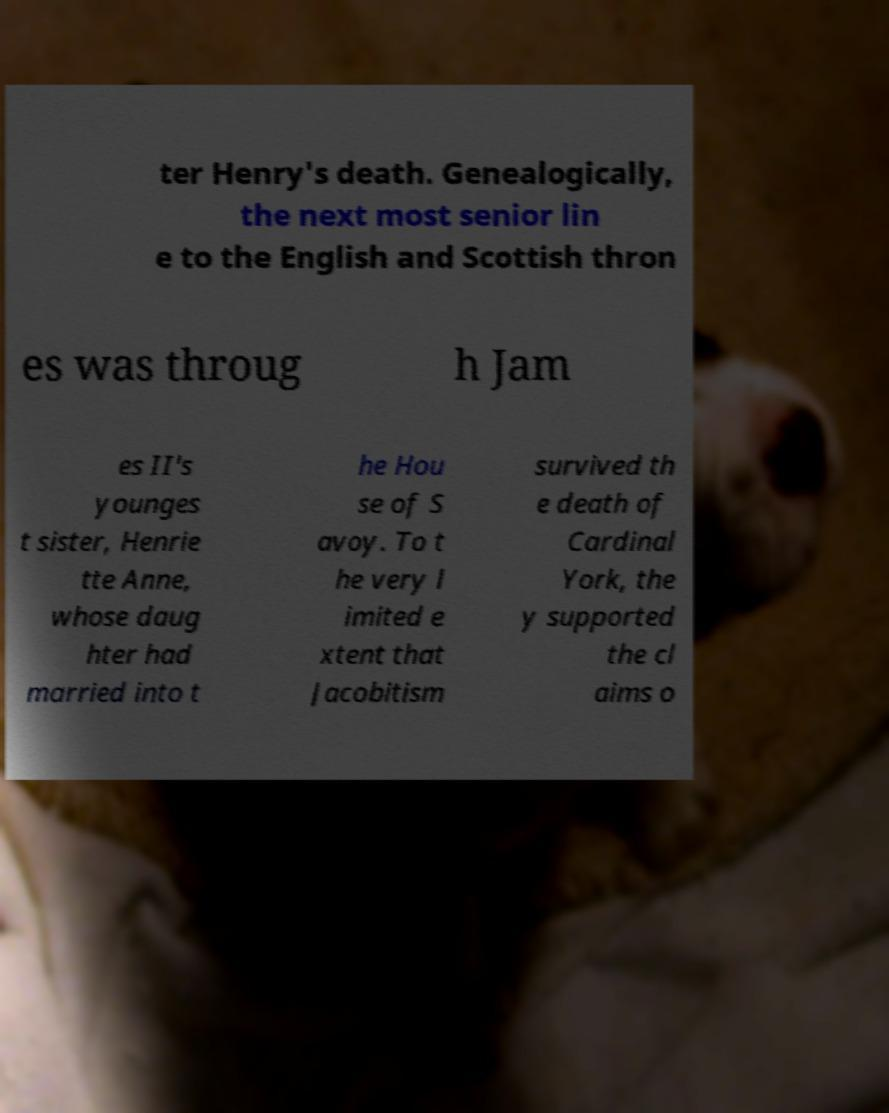Please read and relay the text visible in this image. What does it say? ter Henry's death. Genealogically, the next most senior lin e to the English and Scottish thron es was throug h Jam es II's younges t sister, Henrie tte Anne, whose daug hter had married into t he Hou se of S avoy. To t he very l imited e xtent that Jacobitism survived th e death of Cardinal York, the y supported the cl aims o 